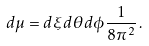<formula> <loc_0><loc_0><loc_500><loc_500>d \mu = d \xi d \theta d \phi \frac { 1 } { 8 \pi ^ { 2 } } \, .</formula> 